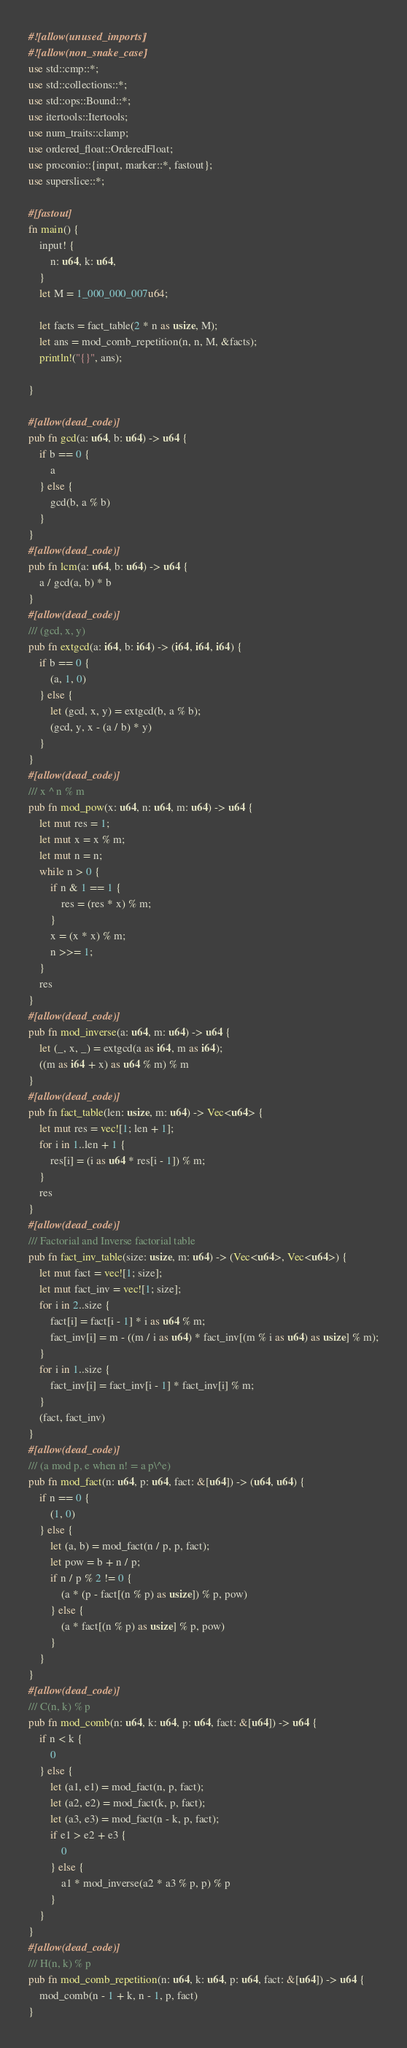Convert code to text. <code><loc_0><loc_0><loc_500><loc_500><_Rust_>#![allow(unused_imports)]
#![allow(non_snake_case)]
use std::cmp::*;
use std::collections::*;
use std::ops::Bound::*;
use itertools::Itertools;
use num_traits::clamp;
use ordered_float::OrderedFloat;
use proconio::{input, marker::*, fastout};
use superslice::*;

#[fastout]
fn main() {
    input! {
        n: u64, k: u64,
    }
    let M = 1_000_000_007u64;

    let facts = fact_table(2 * n as usize, M);
    let ans = mod_comb_repetition(n, n, M, &facts);
    println!("{}", ans);

}

#[allow(dead_code)]
pub fn gcd(a: u64, b: u64) -> u64 {
    if b == 0 {
        a
    } else {
        gcd(b, a % b)
    }
}
#[allow(dead_code)]
pub fn lcm(a: u64, b: u64) -> u64 {
    a / gcd(a, b) * b
}
#[allow(dead_code)]
/// (gcd, x, y)
pub fn extgcd(a: i64, b: i64) -> (i64, i64, i64) {
    if b == 0 {
        (a, 1, 0)
    } else {
        let (gcd, x, y) = extgcd(b, a % b);
        (gcd, y, x - (a / b) * y)
    }
}
#[allow(dead_code)]
/// x ^ n % m
pub fn mod_pow(x: u64, n: u64, m: u64) -> u64 {
    let mut res = 1;
    let mut x = x % m;
    let mut n = n;
    while n > 0 {
        if n & 1 == 1 {
            res = (res * x) % m;
        }
        x = (x * x) % m;
        n >>= 1;
    }
    res
}
#[allow(dead_code)]
pub fn mod_inverse(a: u64, m: u64) -> u64 {
    let (_, x, _) = extgcd(a as i64, m as i64);
    ((m as i64 + x) as u64 % m) % m
}
#[allow(dead_code)]
pub fn fact_table(len: usize, m: u64) -> Vec<u64> {
    let mut res = vec![1; len + 1];
    for i in 1..len + 1 {
        res[i] = (i as u64 * res[i - 1]) % m;
    }
    res
}
#[allow(dead_code)]
/// Factorial and Inverse factorial table
pub fn fact_inv_table(size: usize, m: u64) -> (Vec<u64>, Vec<u64>) {
    let mut fact = vec![1; size];
    let mut fact_inv = vec![1; size];
    for i in 2..size {
        fact[i] = fact[i - 1] * i as u64 % m;
        fact_inv[i] = m - ((m / i as u64) * fact_inv[(m % i as u64) as usize] % m);
    }
    for i in 1..size {
        fact_inv[i] = fact_inv[i - 1] * fact_inv[i] % m;
    }
    (fact, fact_inv)
}
#[allow(dead_code)]
/// (a mod p, e when n! = a p\^e)
pub fn mod_fact(n: u64, p: u64, fact: &[u64]) -> (u64, u64) {
    if n == 0 {
        (1, 0)
    } else {
        let (a, b) = mod_fact(n / p, p, fact);
        let pow = b + n / p;
        if n / p % 2 != 0 {
            (a * (p - fact[(n % p) as usize]) % p, pow)
        } else {
            (a * fact[(n % p) as usize] % p, pow)
        }
    }
}
#[allow(dead_code)]
/// C(n, k) % p
pub fn mod_comb(n: u64, k: u64, p: u64, fact: &[u64]) -> u64 {
    if n < k {
        0
    } else {
        let (a1, e1) = mod_fact(n, p, fact);
        let (a2, e2) = mod_fact(k, p, fact);
        let (a3, e3) = mod_fact(n - k, p, fact);
        if e1 > e2 + e3 {
            0
        } else {
            a1 * mod_inverse(a2 * a3 % p, p) % p
        }
    }
}
#[allow(dead_code)]
/// H(n, k) % p
pub fn mod_comb_repetition(n: u64, k: u64, p: u64, fact: &[u64]) -> u64 {
    mod_comb(n - 1 + k, n - 1, p, fact)
}</code> 